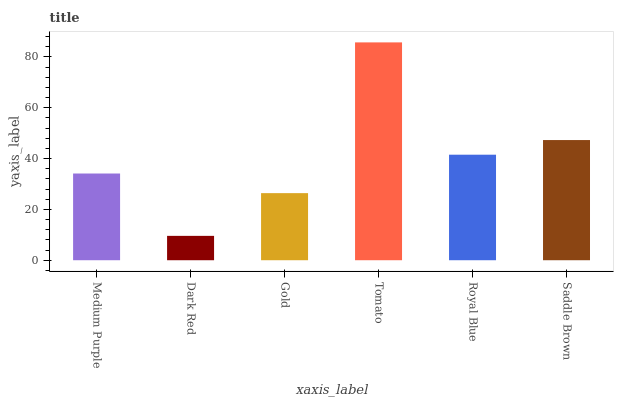Is Dark Red the minimum?
Answer yes or no. Yes. Is Tomato the maximum?
Answer yes or no. Yes. Is Gold the minimum?
Answer yes or no. No. Is Gold the maximum?
Answer yes or no. No. Is Gold greater than Dark Red?
Answer yes or no. Yes. Is Dark Red less than Gold?
Answer yes or no. Yes. Is Dark Red greater than Gold?
Answer yes or no. No. Is Gold less than Dark Red?
Answer yes or no. No. Is Royal Blue the high median?
Answer yes or no. Yes. Is Medium Purple the low median?
Answer yes or no. Yes. Is Saddle Brown the high median?
Answer yes or no. No. Is Dark Red the low median?
Answer yes or no. No. 